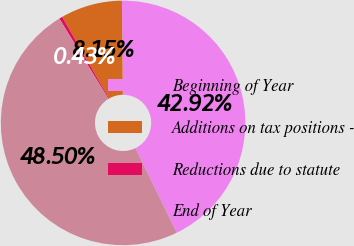Convert chart to OTSL. <chart><loc_0><loc_0><loc_500><loc_500><pie_chart><fcel>Beginning of Year<fcel>Additions on tax positions -<fcel>Reductions due to statute<fcel>End of Year<nl><fcel>42.92%<fcel>8.15%<fcel>0.43%<fcel>48.5%<nl></chart> 